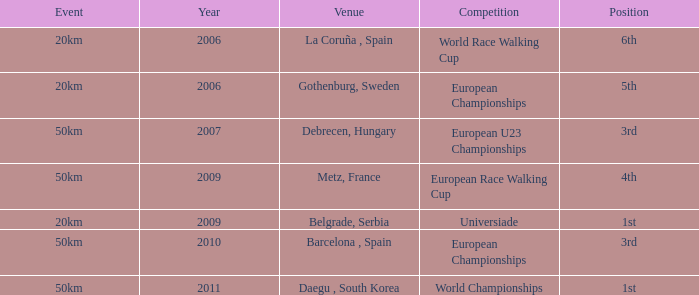What Position is listed against a Venue of Debrecen, Hungary 3rd. 